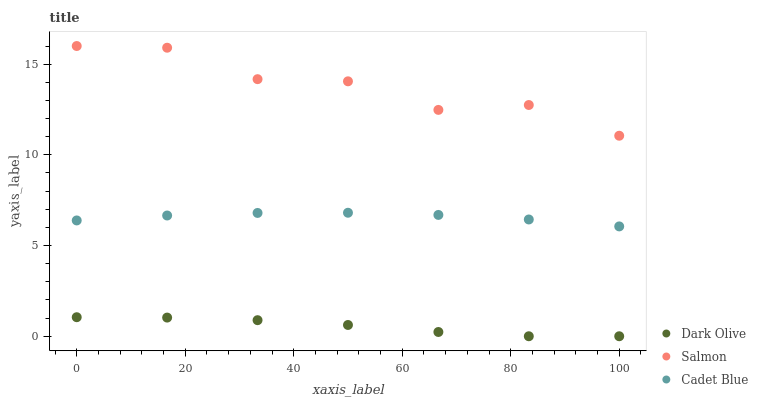Does Dark Olive have the minimum area under the curve?
Answer yes or no. Yes. Does Salmon have the maximum area under the curve?
Answer yes or no. Yes. Does Salmon have the minimum area under the curve?
Answer yes or no. No. Does Dark Olive have the maximum area under the curve?
Answer yes or no. No. Is Cadet Blue the smoothest?
Answer yes or no. Yes. Is Salmon the roughest?
Answer yes or no. Yes. Is Dark Olive the smoothest?
Answer yes or no. No. Is Dark Olive the roughest?
Answer yes or no. No. Does Dark Olive have the lowest value?
Answer yes or no. Yes. Does Salmon have the lowest value?
Answer yes or no. No. Does Salmon have the highest value?
Answer yes or no. Yes. Does Dark Olive have the highest value?
Answer yes or no. No. Is Dark Olive less than Salmon?
Answer yes or no. Yes. Is Salmon greater than Dark Olive?
Answer yes or no. Yes. Does Dark Olive intersect Salmon?
Answer yes or no. No. 